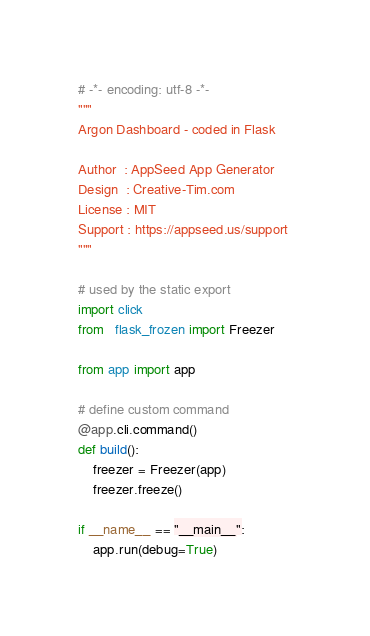Convert code to text. <code><loc_0><loc_0><loc_500><loc_500><_Python_># -*- encoding: utf-8 -*-
"""
Argon Dashboard - coded in Flask

Author  : AppSeed App Generator
Design  : Creative-Tim.com
License : MIT 
Support : https://appseed.us/support 
"""

# used by the static export
import click
from   flask_frozen import Freezer

from app import app

# define custom command 
@app.cli.command()
def build():
    freezer = Freezer(app)
    freezer.freeze()

if __name__ == "__main__":
    app.run(debug=True) 
</code> 